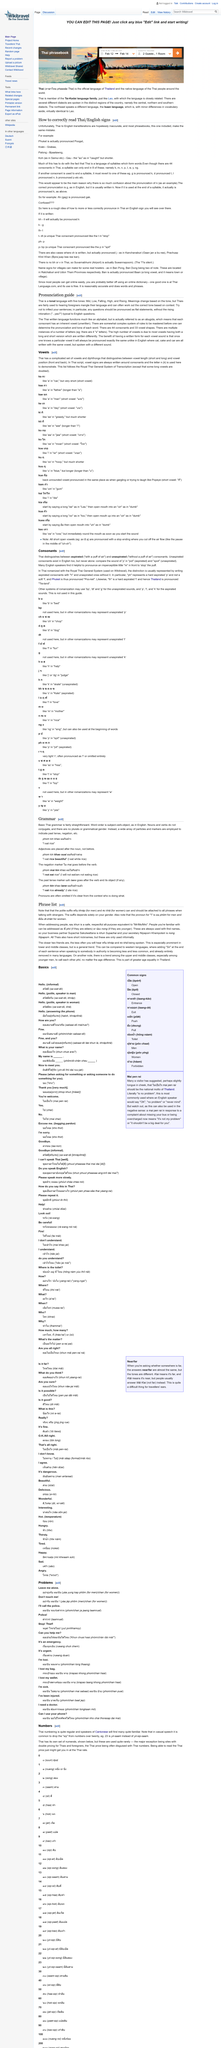Draw attention to some important aspects in this diagram. Thai is a tonal language, as it is characterized by a pitch system that distinguishes words from one another. The pitch system in Thai is a crucial aspect of the language, as it affects the meaning of words and the way they are pronounced. Therefore, it can be confidently declared that Thai is a tonal language. Thai, a language with 44 consonants and 33 vowel shapes, has a significant number of letter forms. Thai has five tones, which distinguish meaning and are an important aspect of the language. 